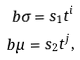Convert formula to latex. <formula><loc_0><loc_0><loc_500><loc_500>b \sigma = s _ { 1 } t ^ { i } \\ b \mu = s _ { 2 } t ^ { j } ,</formula> 